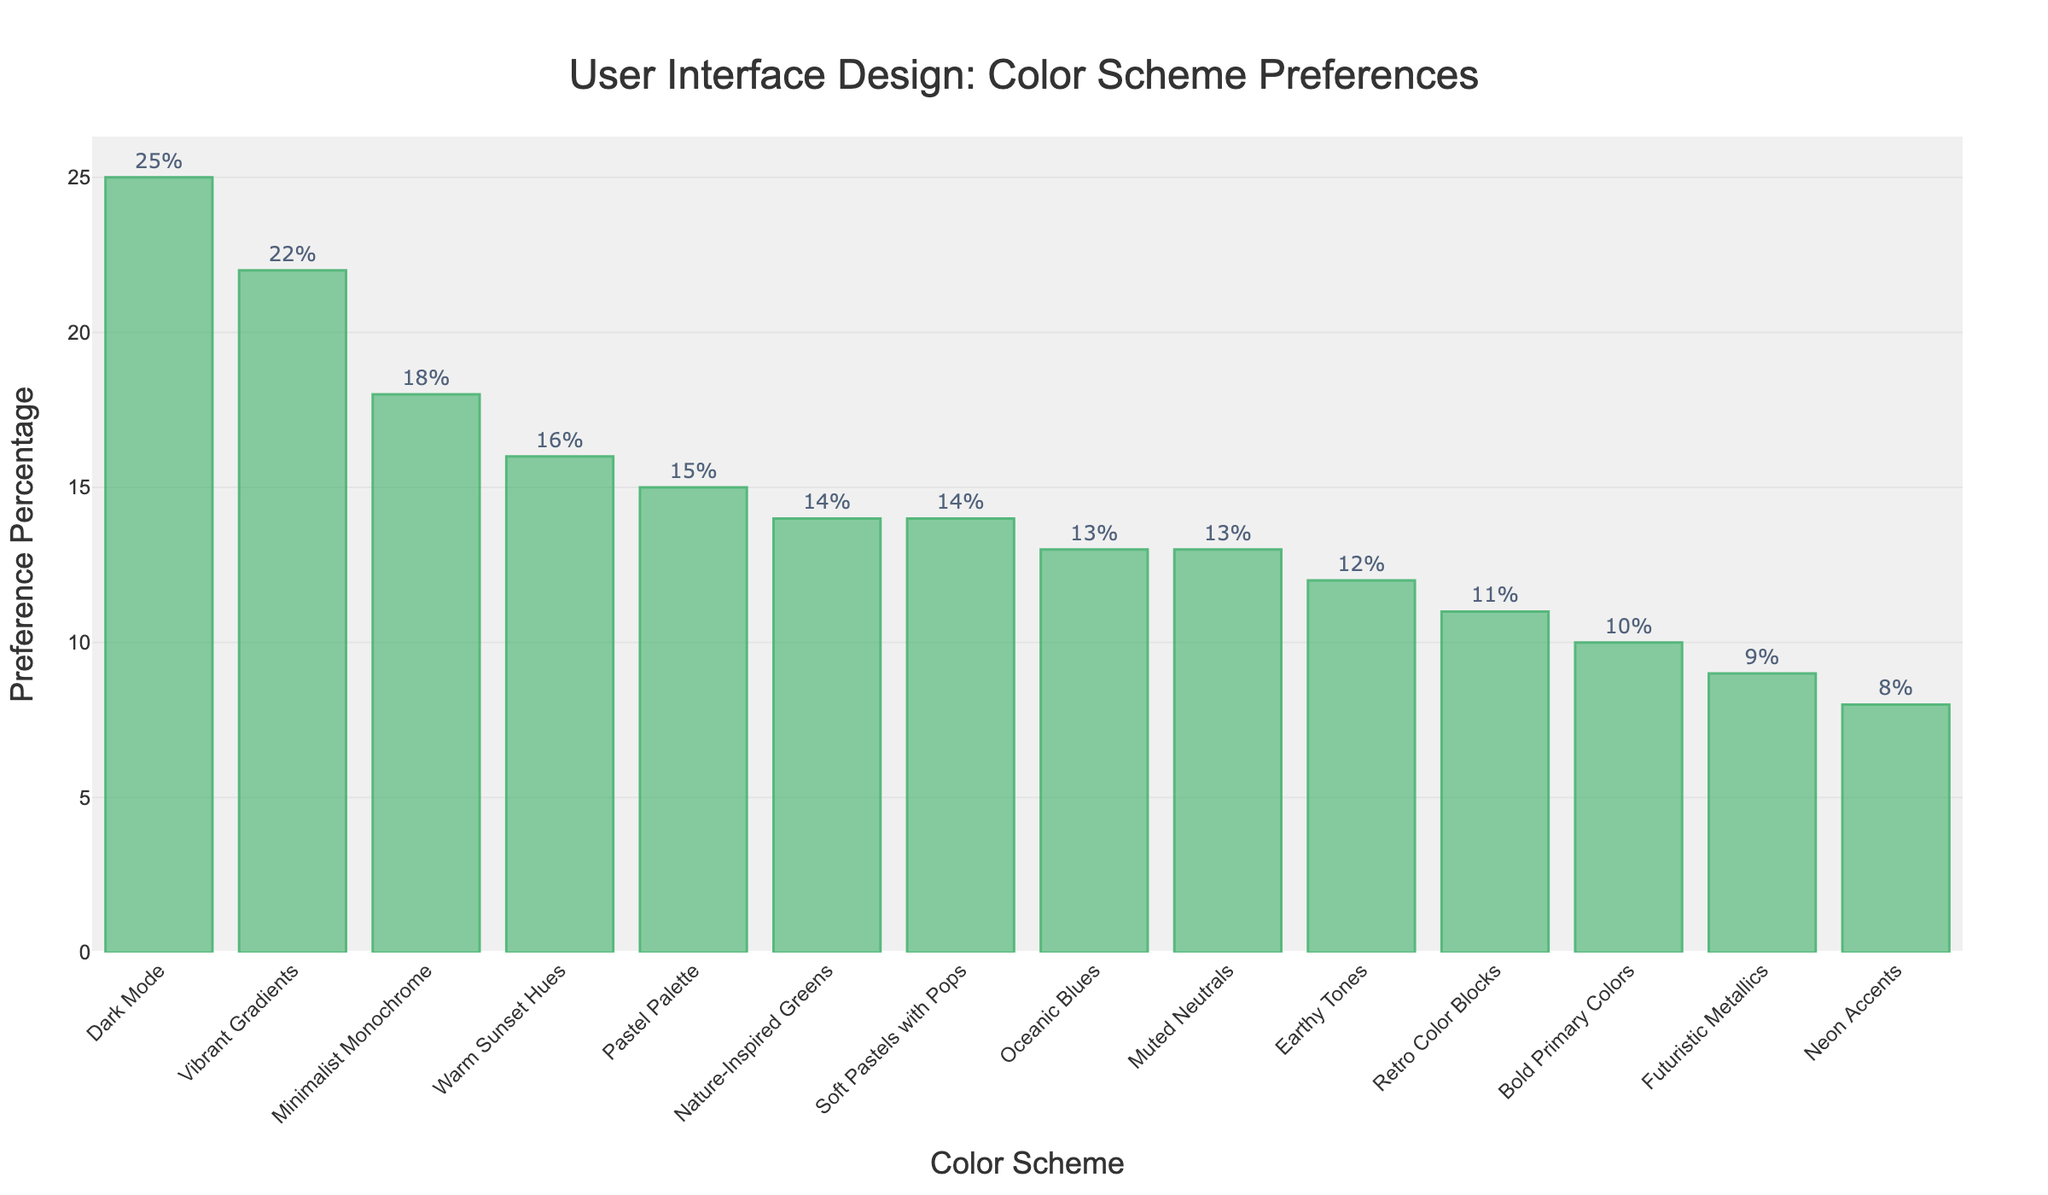What's the most preferred color scheme in user interface design? By examining the heights of the bars, the bar representing "Dark Mode" stands out as the tallest, indicating it has the highest preference percentage.
Answer: Dark Mode Which color scheme has the lowest preference percentage? By looking for the shortest bar in the figure, the "Neon Accents" bar is the shortest and thus has the lowest preference.
Answer: Neon Accents How much more preferred is "Pastel Palette" compared to "Bold Primary Colors"? The preference for "Pastel Palette" is 15%, while the preference for "Bold Primary Colors" is 10%. The difference is 15% - 10% = 5%.
Answer: 5% What is the average preference percentage for "Minimalist Monochrome", "Vibrant Gradients", "Earthy Tones", and "Pastel Palette"? Summing their preferences: 18% + 22% + 12% + 15% = 67%. Dividing by the number of schemes (4) gives the average: 67% / 4 = 16.75%.
Answer: 16.75% Which color scheme has a preference percentage closest to the median of all the displayed preferences? First, we list the preferences in ascending order: 8, 9, 10, 11, 12, 13, 13, 14, 14, 15, 16, 18, 22, 25. The median values are the 7th and 8th values: 13 and 14. The median is (13 + 14)/2 = 13.5. "Muted Neutrals" and "Nature-Inspired Greens", both at 13%, are the closest to this median.
Answer: Muted Neutrals and Nature-Inspired Greens What is the total preference percentage for all color schemes combined? Summing all given percentages: 18% + 22% + 12% + 15% + 25% + 8% + 11% + 14% + 13% + 16% + 9% + 13% + 10% + 14% = 200%.
Answer: 200% Is "Futuristic Metallics" preferred more or less than "Pastel Palette"? The bar for "Futuristic Metallics" has a preference percentage of 9%, while "Pastel Palette" is 15%. Since 9% < 15%, "Futuristic Metallics" is less preferred.
Answer: Less What is the difference in preference percentage between "Dark Mode" and the least preferred scheme? "Dark Mode" has a preference of 25%, and "Neon Accents" (the least preferred) has 8%. The difference is 25% - 8% = 17%.
Answer: 17% Which color schemes have a preference percentage of 13%? By inspecting the figure, "Oceanic Blues" and "Muted Neutrals" both show a preference percentage of 13%.
Answer: Oceanic Blues and Muted Neutrals How does the preference percentage for "Vibrant Gradients" compare to the average of all schemes? First, calculate the average of all preferences: total is 200%, divided by the number of schemes (14) gives 200% / 14 ≈ 14.3%. "Vibrant Gradients" at 22% is higher than this average.
Answer: Higher 